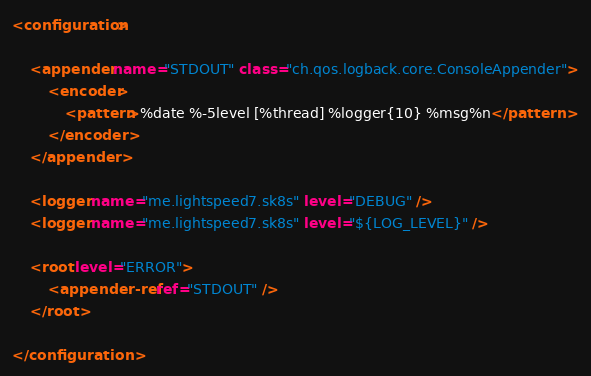Convert code to text. <code><loc_0><loc_0><loc_500><loc_500><_XML_><configuration>

    <appender name="STDOUT" class="ch.qos.logback.core.ConsoleAppender">
        <encoder>
            <pattern>%date %-5level [%thread] %logger{10} %msg%n</pattern>
        </encoder>
    </appender>

    <logger name="me.lightspeed7.sk8s" level="DEBUG" />
    <logger name="me.lightspeed7.sk8s" level="${LOG_LEVEL}" />

    <root level="ERROR">
        <appender-ref ref="STDOUT" />
    </root>

</configuration>
</code> 